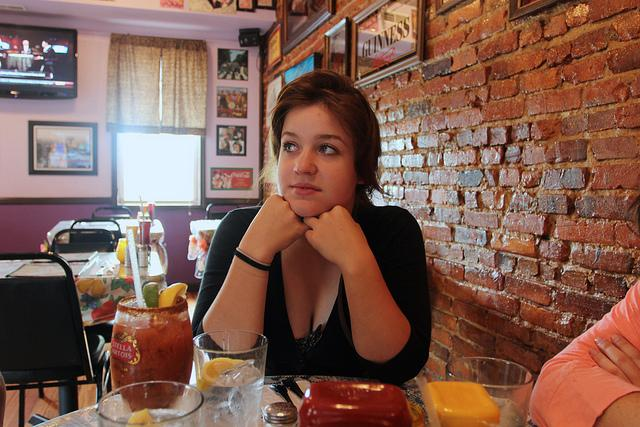What is held in the red and yellow containers on the table? ketchup mustard 